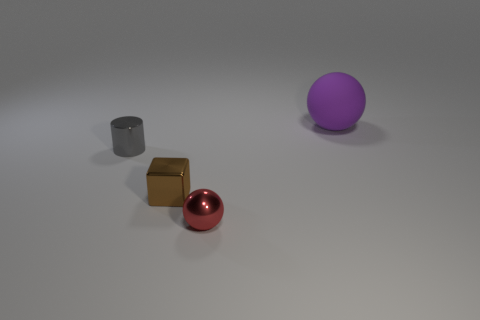Add 2 metallic cylinders. How many objects exist? 6 Subtract all blocks. How many objects are left? 3 Add 3 small brown metallic cylinders. How many small brown metallic cylinders exist? 3 Subtract 0 blue cylinders. How many objects are left? 4 Subtract all tiny red shiny balls. Subtract all small brown shiny objects. How many objects are left? 2 Add 4 purple spheres. How many purple spheres are left? 5 